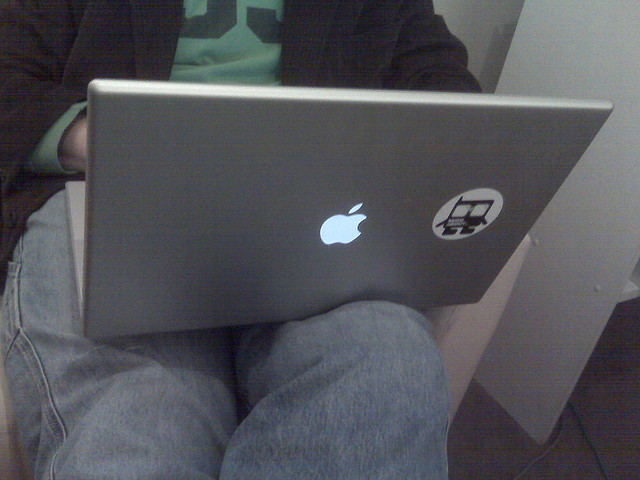<image>What is the word on the lid of the laptop? I am not sure what is the word on the lid of the laptop. It can be either none or apple. What work is repeated in the sticker on the computer? I don't know what work is repeated in the sticker on the computer. It could be 'square', 'apple', 'computer', 'windows', 'driver', 'phone calls', 'dancing' or 'cell phones'. What print is on this person's pants? I am not sure what print is on this person's pants. It can be solid, denim, or jeans. What is the word on the lid of the laptop? I don't know what is written on the lid of the laptop. It can be either 'apple' or 'no word'. What print is on this person's pants? I don't know what print is on this person's pants. It can be solid, denim, jeans, or plain. What work is repeated in the sticker on the computer? The work repeated in the sticker on the computer is unclear. It can be seen as 'square', 'apple', 'computer', 'windows', 'driver', 'phone calls', 'dancing' or 'cell phones'. 